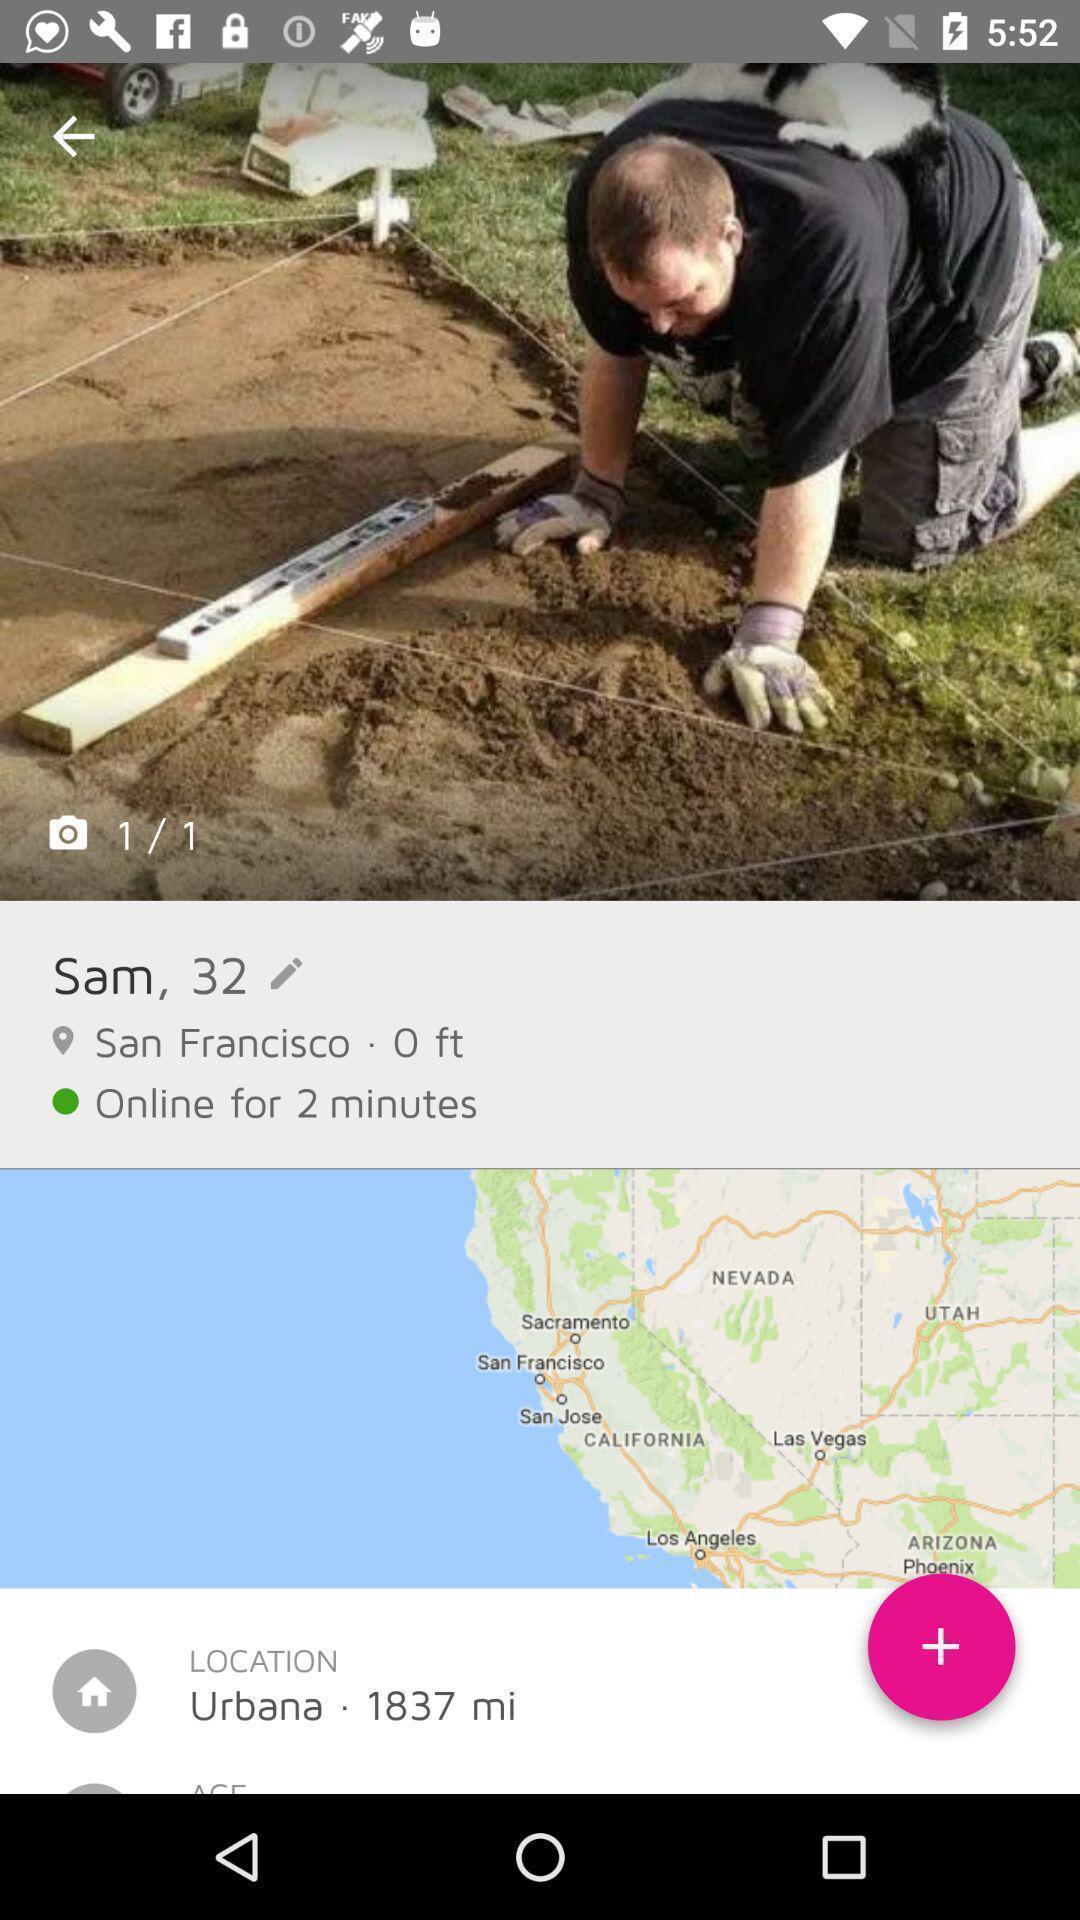Explain what's happening in this screen capture. Screen shows image of a person and location. 